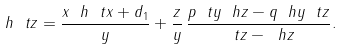Convert formula to latex. <formula><loc_0><loc_0><loc_500><loc_500>\ h { \ t z } = \frac { x \ h { \ t x } + d _ { 1 } } { y } + \frac { z } y \, \frac { p \ t y \ h z - q \ h y \ t z } { \ t z - \ h z } .</formula> 